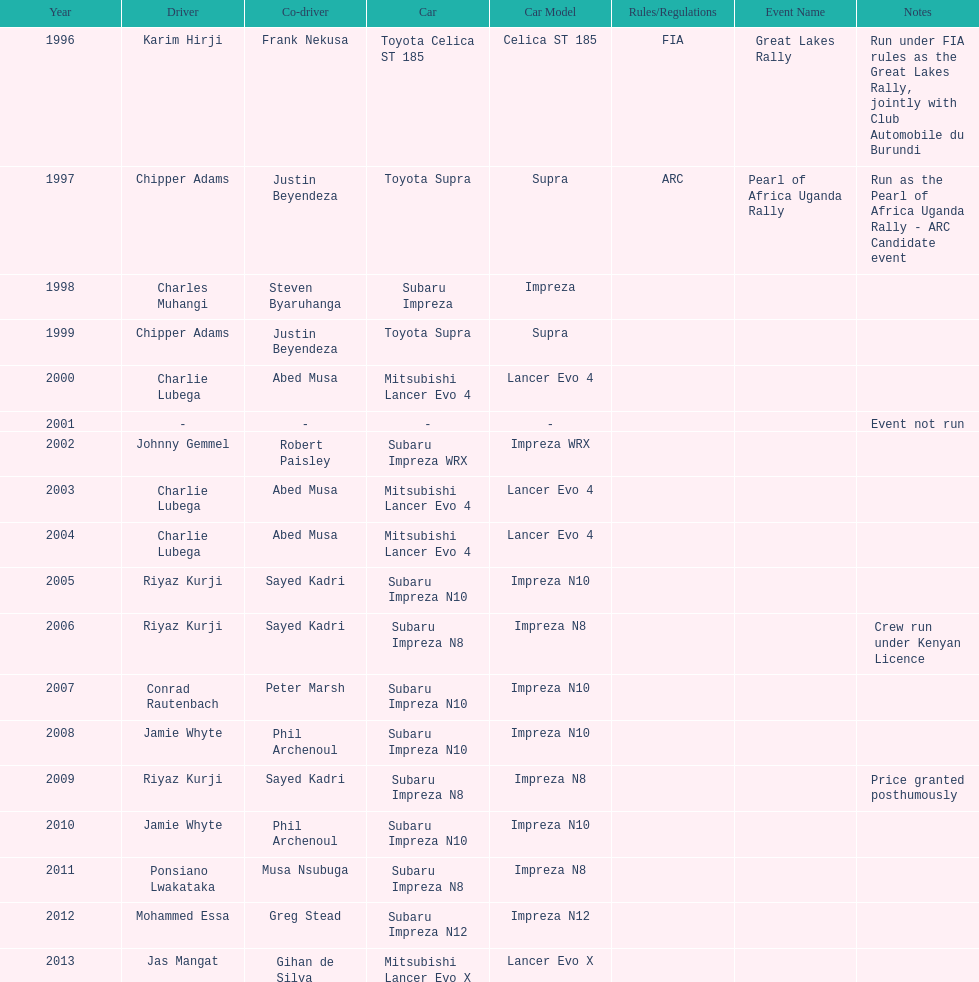Which driver won after ponsiano lwakataka? Mohammed Essa. 